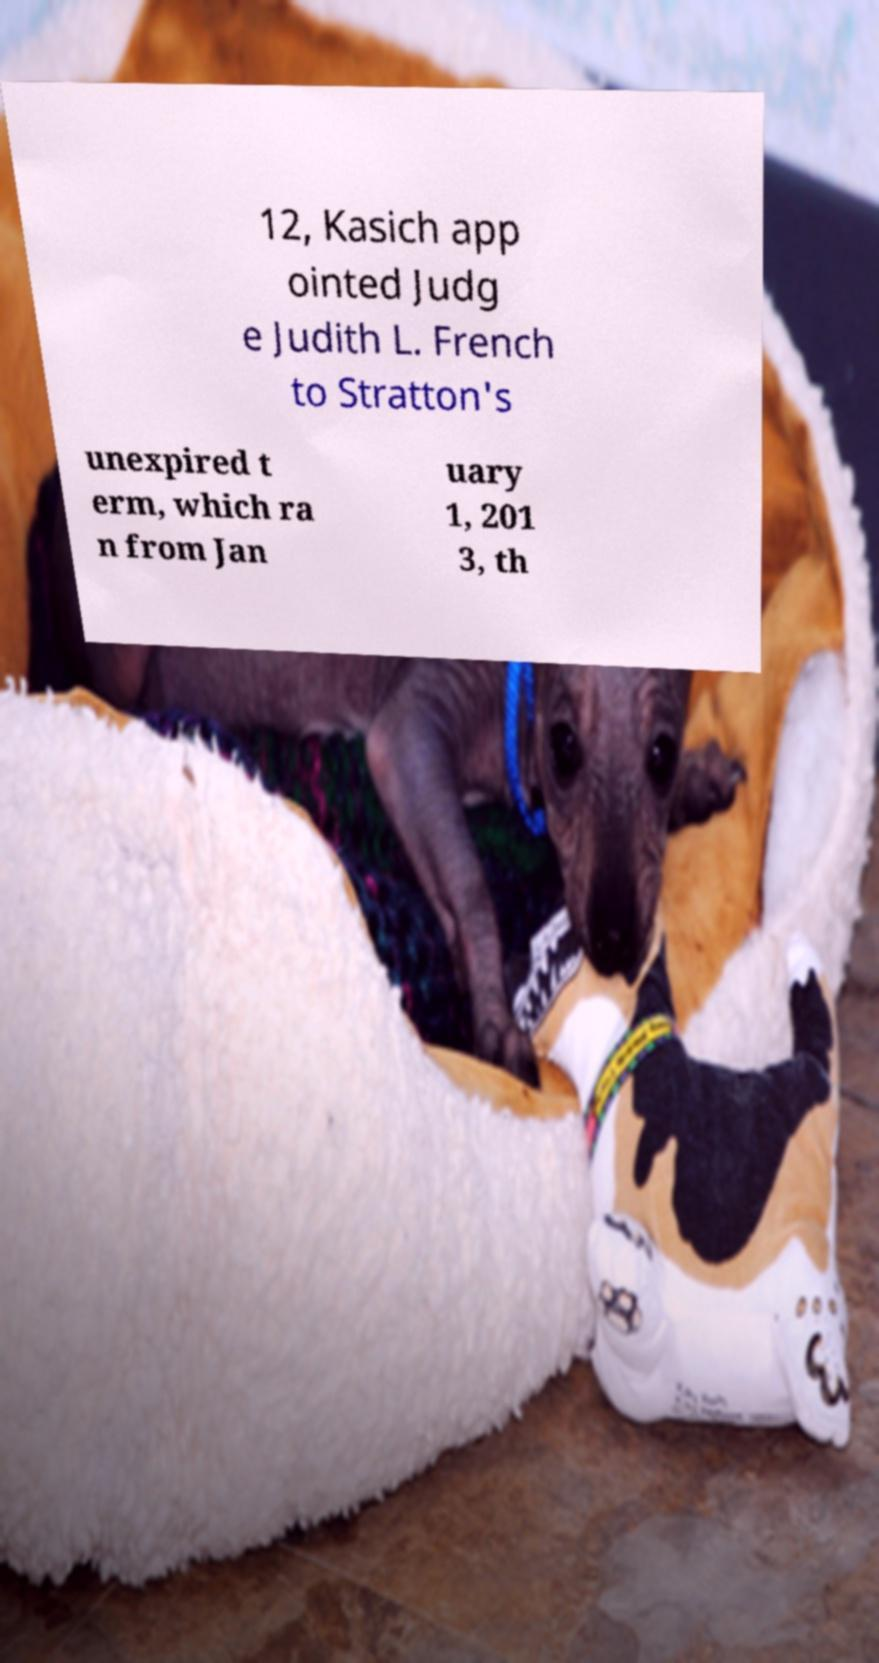What messages or text are displayed in this image? I need them in a readable, typed format. 12, Kasich app ointed Judg e Judith L. French to Stratton's unexpired t erm, which ra n from Jan uary 1, 201 3, th 